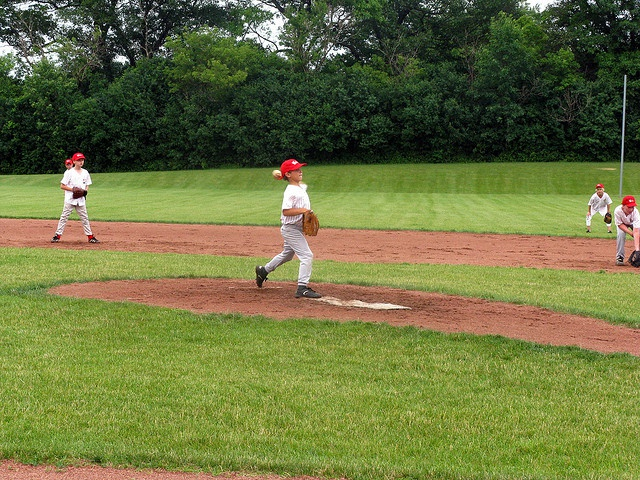Describe the objects in this image and their specific colors. I can see people in darkgreen, lightgray, darkgray, gray, and brown tones, people in darkgreen, white, darkgray, brown, and lightpink tones, people in darkgreen, lavender, lightpink, darkgray, and brown tones, people in darkgreen, lightgray, darkgray, tan, and brown tones, and baseball glove in darkgreen, brown, and maroon tones in this image. 